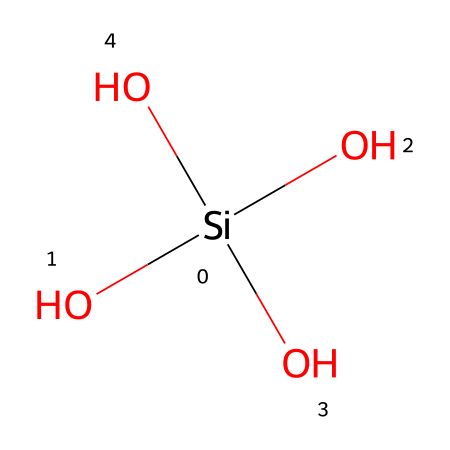What is the central atom in this chemical structure? The central atom is silicon, which can be identified as it is the atom that is bonded to multiple oxygen atoms in the structure.
Answer: silicon How many oxygen atoms are bonded to the central silicon atom? The structure shows that there are four oxygen atoms connected to the silicon atom, indicated by the number of O atoms in the SMILES representation.
Answer: four What type of bonds are formed between silicon and oxygen in this chemical? The bonds are covalent; silicon forms these bonds with oxygen due to the sharing of electrons, which is typical in silicon-oxygen compounds.
Answer: covalent What is the significance of silica in ceramic glazes? Silica is crucial for forming glassy phases in ceramic glazes, contributing to their durability, brightness, and surface quality, as it helps create a network structure when fired.
Answer: glassy phases Which property of this chemical contributes to its high melting point often seen in ceramics? The strong covalent bonds between silicon and oxygen create a stable, three-dimensional structure, leading to a high melting point characteristic of silica-containing compounds.
Answer: strong covalent bonds How does silica affect the viscosity of ceramic glazes? The presence of silica increases the viscosity of the glaze when melted, as its complex network structure resists flow, impacting the glaze's application and final texture.
Answer: increases viscosity 